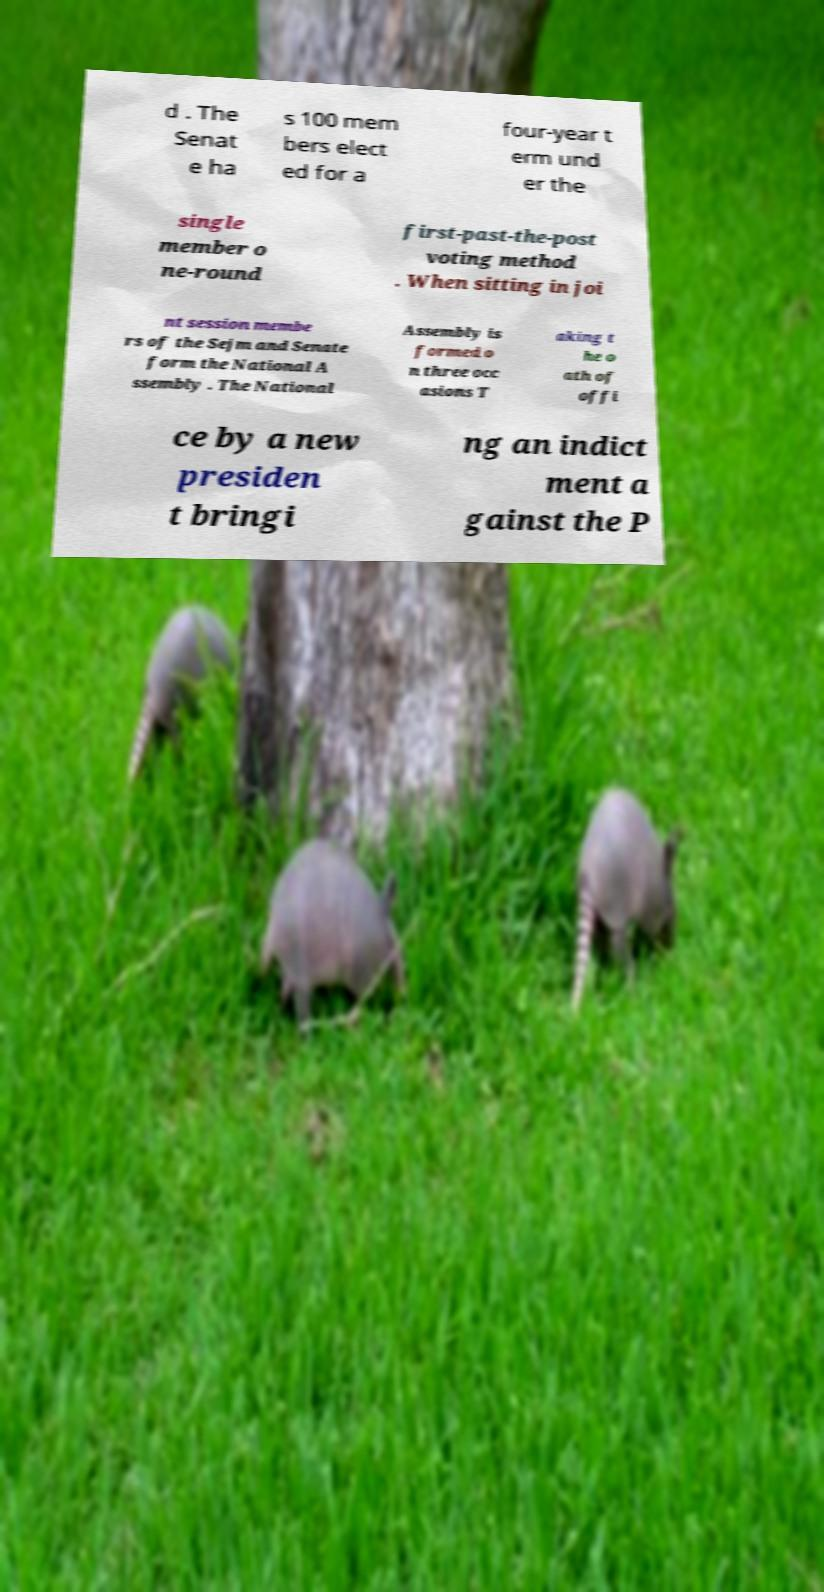I need the written content from this picture converted into text. Can you do that? d . The Senat e ha s 100 mem bers elect ed for a four-year t erm und er the single member o ne-round first-past-the-post voting method . When sitting in joi nt session membe rs of the Sejm and Senate form the National A ssembly . The National Assembly is formed o n three occ asions T aking t he o ath of offi ce by a new presiden t bringi ng an indict ment a gainst the P 